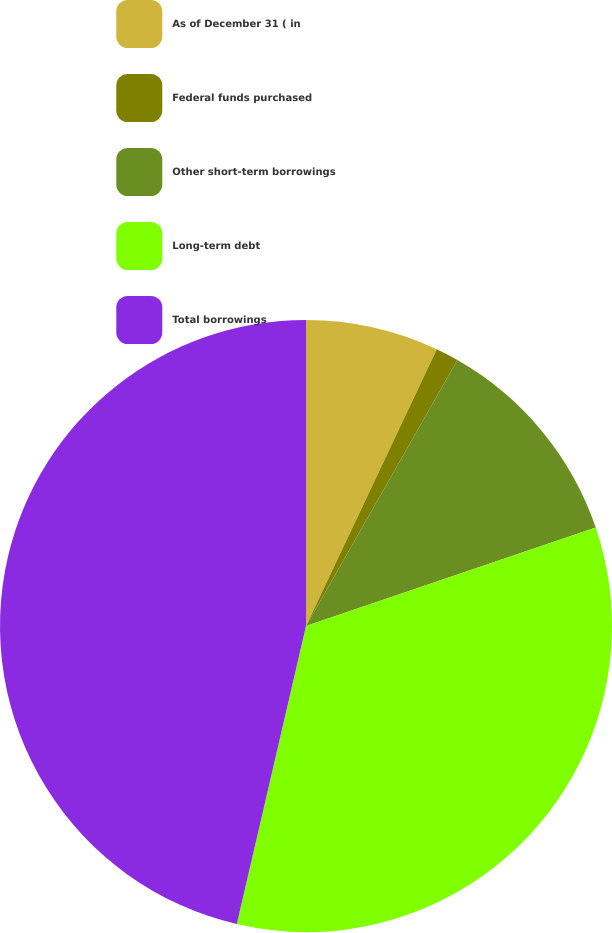Convert chart. <chart><loc_0><loc_0><loc_500><loc_500><pie_chart><fcel>As of December 31 ( in<fcel>Federal funds purchased<fcel>Other short-term borrowings<fcel>Long-term debt<fcel>Total borrowings<nl><fcel>7.03%<fcel>1.21%<fcel>11.55%<fcel>33.84%<fcel>46.37%<nl></chart> 